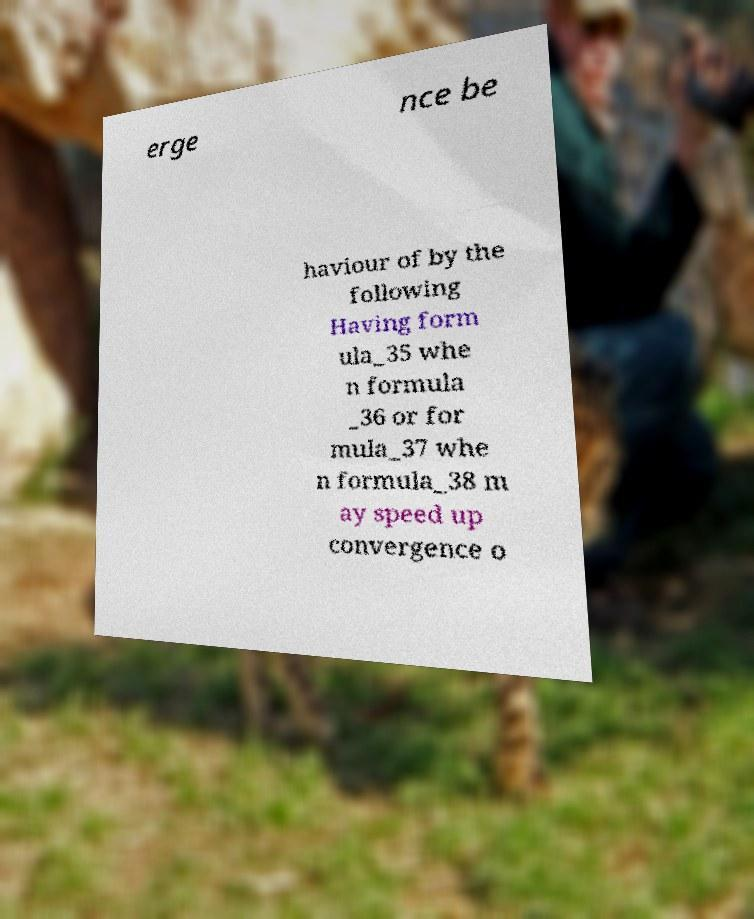For documentation purposes, I need the text within this image transcribed. Could you provide that? erge nce be haviour of by the following Having form ula_35 whe n formula _36 or for mula_37 whe n formula_38 m ay speed up convergence o 